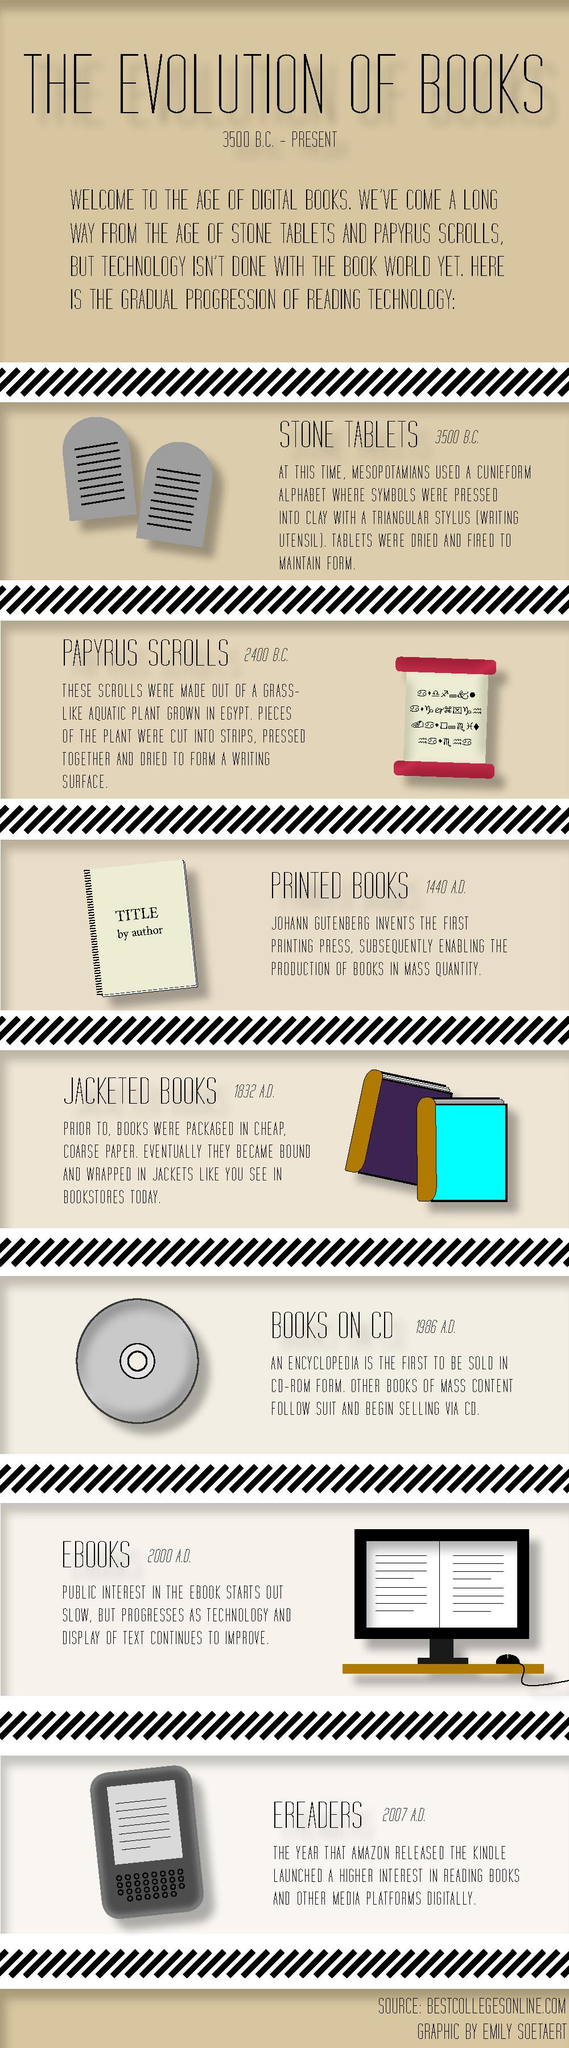List a handful of essential elements in this visual. The first printing press was invented in 1440 A.D. I declare that the publication of books in digital form is known as eBooks. Ereaders are devices that are used for reading digital e-books. 